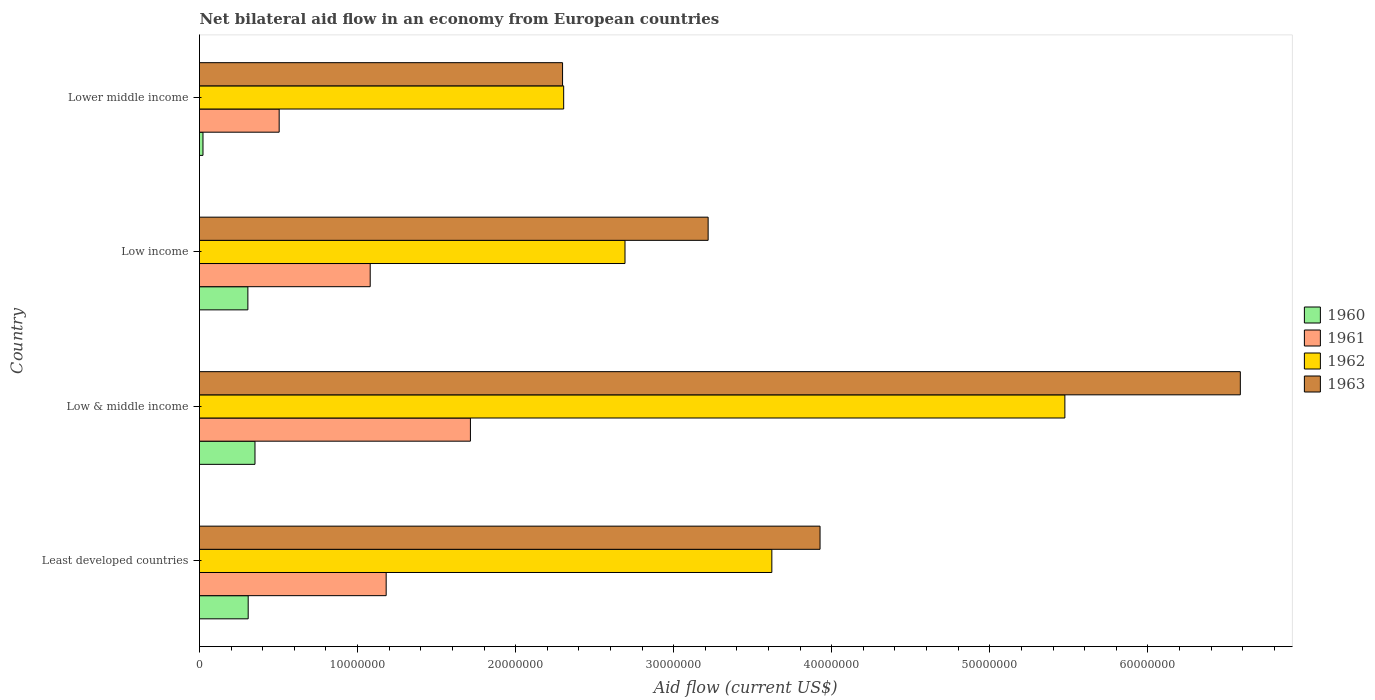How many different coloured bars are there?
Offer a terse response. 4. Are the number of bars per tick equal to the number of legend labels?
Offer a very short reply. Yes. Are the number of bars on each tick of the Y-axis equal?
Provide a short and direct response. Yes. How many bars are there on the 1st tick from the top?
Offer a terse response. 4. What is the label of the 2nd group of bars from the top?
Provide a succinct answer. Low income. What is the net bilateral aid flow in 1961 in Lower middle income?
Your answer should be compact. 5.04e+06. Across all countries, what is the maximum net bilateral aid flow in 1963?
Give a very brief answer. 6.58e+07. Across all countries, what is the minimum net bilateral aid flow in 1962?
Offer a terse response. 2.30e+07. In which country was the net bilateral aid flow in 1962 maximum?
Ensure brevity in your answer.  Low & middle income. In which country was the net bilateral aid flow in 1961 minimum?
Your answer should be very brief. Lower middle income. What is the total net bilateral aid flow in 1961 in the graph?
Offer a very short reply. 4.48e+07. What is the difference between the net bilateral aid flow in 1963 in Low & middle income and that in Low income?
Offer a very short reply. 3.37e+07. What is the difference between the net bilateral aid flow in 1962 in Lower middle income and the net bilateral aid flow in 1961 in Low income?
Give a very brief answer. 1.22e+07. What is the average net bilateral aid flow in 1961 per country?
Offer a terse response. 1.12e+07. What is the difference between the net bilateral aid flow in 1960 and net bilateral aid flow in 1963 in Lower middle income?
Offer a terse response. -2.28e+07. What is the ratio of the net bilateral aid flow in 1963 in Least developed countries to that in Low & middle income?
Make the answer very short. 0.6. Is the net bilateral aid flow in 1962 in Least developed countries less than that in Low income?
Offer a terse response. No. What is the difference between the highest and the second highest net bilateral aid flow in 1962?
Provide a succinct answer. 1.85e+07. What is the difference between the highest and the lowest net bilateral aid flow in 1963?
Provide a short and direct response. 4.29e+07. In how many countries, is the net bilateral aid flow in 1962 greater than the average net bilateral aid flow in 1962 taken over all countries?
Your response must be concise. 2. Is it the case that in every country, the sum of the net bilateral aid flow in 1961 and net bilateral aid flow in 1960 is greater than the sum of net bilateral aid flow in 1963 and net bilateral aid flow in 1962?
Your answer should be very brief. No. What does the 1st bar from the top in Lower middle income represents?
Give a very brief answer. 1963. Is it the case that in every country, the sum of the net bilateral aid flow in 1960 and net bilateral aid flow in 1961 is greater than the net bilateral aid flow in 1963?
Your answer should be compact. No. Are all the bars in the graph horizontal?
Your answer should be very brief. Yes. How many countries are there in the graph?
Your answer should be compact. 4. What is the difference between two consecutive major ticks on the X-axis?
Your answer should be very brief. 1.00e+07. Are the values on the major ticks of X-axis written in scientific E-notation?
Offer a terse response. No. How many legend labels are there?
Give a very brief answer. 4. How are the legend labels stacked?
Ensure brevity in your answer.  Vertical. What is the title of the graph?
Give a very brief answer. Net bilateral aid flow in an economy from European countries. Does "1988" appear as one of the legend labels in the graph?
Your answer should be very brief. No. What is the Aid flow (current US$) in 1960 in Least developed countries?
Keep it short and to the point. 3.08e+06. What is the Aid flow (current US$) in 1961 in Least developed countries?
Your response must be concise. 1.18e+07. What is the Aid flow (current US$) in 1962 in Least developed countries?
Your answer should be compact. 3.62e+07. What is the Aid flow (current US$) of 1963 in Least developed countries?
Offer a terse response. 3.93e+07. What is the Aid flow (current US$) of 1960 in Low & middle income?
Keep it short and to the point. 3.51e+06. What is the Aid flow (current US$) of 1961 in Low & middle income?
Your answer should be very brief. 1.71e+07. What is the Aid flow (current US$) in 1962 in Low & middle income?
Your answer should be compact. 5.48e+07. What is the Aid flow (current US$) in 1963 in Low & middle income?
Provide a short and direct response. 6.58e+07. What is the Aid flow (current US$) of 1960 in Low income?
Offer a terse response. 3.06e+06. What is the Aid flow (current US$) in 1961 in Low income?
Your answer should be very brief. 1.08e+07. What is the Aid flow (current US$) in 1962 in Low income?
Ensure brevity in your answer.  2.69e+07. What is the Aid flow (current US$) of 1963 in Low income?
Give a very brief answer. 3.22e+07. What is the Aid flow (current US$) of 1960 in Lower middle income?
Your answer should be very brief. 2.20e+05. What is the Aid flow (current US$) in 1961 in Lower middle income?
Make the answer very short. 5.04e+06. What is the Aid flow (current US$) in 1962 in Lower middle income?
Ensure brevity in your answer.  2.30e+07. What is the Aid flow (current US$) in 1963 in Lower middle income?
Ensure brevity in your answer.  2.30e+07. Across all countries, what is the maximum Aid flow (current US$) of 1960?
Provide a short and direct response. 3.51e+06. Across all countries, what is the maximum Aid flow (current US$) of 1961?
Offer a terse response. 1.71e+07. Across all countries, what is the maximum Aid flow (current US$) in 1962?
Make the answer very short. 5.48e+07. Across all countries, what is the maximum Aid flow (current US$) in 1963?
Offer a very short reply. 6.58e+07. Across all countries, what is the minimum Aid flow (current US$) in 1961?
Your answer should be very brief. 5.04e+06. Across all countries, what is the minimum Aid flow (current US$) of 1962?
Provide a short and direct response. 2.30e+07. Across all countries, what is the minimum Aid flow (current US$) of 1963?
Give a very brief answer. 2.30e+07. What is the total Aid flow (current US$) in 1960 in the graph?
Offer a terse response. 9.87e+06. What is the total Aid flow (current US$) of 1961 in the graph?
Offer a terse response. 4.48e+07. What is the total Aid flow (current US$) of 1962 in the graph?
Make the answer very short. 1.41e+08. What is the total Aid flow (current US$) of 1963 in the graph?
Provide a succinct answer. 1.60e+08. What is the difference between the Aid flow (current US$) in 1960 in Least developed countries and that in Low & middle income?
Your answer should be compact. -4.30e+05. What is the difference between the Aid flow (current US$) in 1961 in Least developed countries and that in Low & middle income?
Make the answer very short. -5.33e+06. What is the difference between the Aid flow (current US$) of 1962 in Least developed countries and that in Low & middle income?
Offer a terse response. -1.85e+07. What is the difference between the Aid flow (current US$) in 1963 in Least developed countries and that in Low & middle income?
Provide a short and direct response. -2.66e+07. What is the difference between the Aid flow (current US$) of 1961 in Least developed countries and that in Low income?
Provide a short and direct response. 1.01e+06. What is the difference between the Aid flow (current US$) in 1962 in Least developed countries and that in Low income?
Provide a short and direct response. 9.29e+06. What is the difference between the Aid flow (current US$) in 1963 in Least developed countries and that in Low income?
Your answer should be very brief. 7.08e+06. What is the difference between the Aid flow (current US$) of 1960 in Least developed countries and that in Lower middle income?
Make the answer very short. 2.86e+06. What is the difference between the Aid flow (current US$) of 1961 in Least developed countries and that in Lower middle income?
Give a very brief answer. 6.77e+06. What is the difference between the Aid flow (current US$) of 1962 in Least developed countries and that in Lower middle income?
Provide a short and direct response. 1.32e+07. What is the difference between the Aid flow (current US$) of 1963 in Least developed countries and that in Lower middle income?
Keep it short and to the point. 1.63e+07. What is the difference between the Aid flow (current US$) of 1961 in Low & middle income and that in Low income?
Keep it short and to the point. 6.34e+06. What is the difference between the Aid flow (current US$) of 1962 in Low & middle income and that in Low income?
Your response must be concise. 2.78e+07. What is the difference between the Aid flow (current US$) of 1963 in Low & middle income and that in Low income?
Your answer should be very brief. 3.37e+07. What is the difference between the Aid flow (current US$) of 1960 in Low & middle income and that in Lower middle income?
Your answer should be compact. 3.29e+06. What is the difference between the Aid flow (current US$) in 1961 in Low & middle income and that in Lower middle income?
Provide a succinct answer. 1.21e+07. What is the difference between the Aid flow (current US$) of 1962 in Low & middle income and that in Lower middle income?
Ensure brevity in your answer.  3.17e+07. What is the difference between the Aid flow (current US$) in 1963 in Low & middle income and that in Lower middle income?
Provide a succinct answer. 4.29e+07. What is the difference between the Aid flow (current US$) in 1960 in Low income and that in Lower middle income?
Provide a short and direct response. 2.84e+06. What is the difference between the Aid flow (current US$) in 1961 in Low income and that in Lower middle income?
Provide a short and direct response. 5.76e+06. What is the difference between the Aid flow (current US$) in 1962 in Low income and that in Lower middle income?
Offer a terse response. 3.88e+06. What is the difference between the Aid flow (current US$) in 1963 in Low income and that in Lower middle income?
Offer a very short reply. 9.21e+06. What is the difference between the Aid flow (current US$) of 1960 in Least developed countries and the Aid flow (current US$) of 1961 in Low & middle income?
Offer a terse response. -1.41e+07. What is the difference between the Aid flow (current US$) in 1960 in Least developed countries and the Aid flow (current US$) in 1962 in Low & middle income?
Ensure brevity in your answer.  -5.17e+07. What is the difference between the Aid flow (current US$) of 1960 in Least developed countries and the Aid flow (current US$) of 1963 in Low & middle income?
Keep it short and to the point. -6.28e+07. What is the difference between the Aid flow (current US$) of 1961 in Least developed countries and the Aid flow (current US$) of 1962 in Low & middle income?
Keep it short and to the point. -4.29e+07. What is the difference between the Aid flow (current US$) of 1961 in Least developed countries and the Aid flow (current US$) of 1963 in Low & middle income?
Provide a short and direct response. -5.40e+07. What is the difference between the Aid flow (current US$) in 1962 in Least developed countries and the Aid flow (current US$) in 1963 in Low & middle income?
Your answer should be very brief. -2.96e+07. What is the difference between the Aid flow (current US$) of 1960 in Least developed countries and the Aid flow (current US$) of 1961 in Low income?
Your answer should be very brief. -7.72e+06. What is the difference between the Aid flow (current US$) of 1960 in Least developed countries and the Aid flow (current US$) of 1962 in Low income?
Ensure brevity in your answer.  -2.38e+07. What is the difference between the Aid flow (current US$) of 1960 in Least developed countries and the Aid flow (current US$) of 1963 in Low income?
Keep it short and to the point. -2.91e+07. What is the difference between the Aid flow (current US$) of 1961 in Least developed countries and the Aid flow (current US$) of 1962 in Low income?
Ensure brevity in your answer.  -1.51e+07. What is the difference between the Aid flow (current US$) of 1961 in Least developed countries and the Aid flow (current US$) of 1963 in Low income?
Your answer should be compact. -2.04e+07. What is the difference between the Aid flow (current US$) of 1962 in Least developed countries and the Aid flow (current US$) of 1963 in Low income?
Offer a very short reply. 4.03e+06. What is the difference between the Aid flow (current US$) in 1960 in Least developed countries and the Aid flow (current US$) in 1961 in Lower middle income?
Your answer should be very brief. -1.96e+06. What is the difference between the Aid flow (current US$) in 1960 in Least developed countries and the Aid flow (current US$) in 1962 in Lower middle income?
Give a very brief answer. -2.00e+07. What is the difference between the Aid flow (current US$) in 1960 in Least developed countries and the Aid flow (current US$) in 1963 in Lower middle income?
Provide a succinct answer. -1.99e+07. What is the difference between the Aid flow (current US$) of 1961 in Least developed countries and the Aid flow (current US$) of 1962 in Lower middle income?
Your answer should be compact. -1.12e+07. What is the difference between the Aid flow (current US$) in 1961 in Least developed countries and the Aid flow (current US$) in 1963 in Lower middle income?
Offer a very short reply. -1.12e+07. What is the difference between the Aid flow (current US$) in 1962 in Least developed countries and the Aid flow (current US$) in 1963 in Lower middle income?
Offer a terse response. 1.32e+07. What is the difference between the Aid flow (current US$) of 1960 in Low & middle income and the Aid flow (current US$) of 1961 in Low income?
Your answer should be very brief. -7.29e+06. What is the difference between the Aid flow (current US$) of 1960 in Low & middle income and the Aid flow (current US$) of 1962 in Low income?
Make the answer very short. -2.34e+07. What is the difference between the Aid flow (current US$) of 1960 in Low & middle income and the Aid flow (current US$) of 1963 in Low income?
Ensure brevity in your answer.  -2.87e+07. What is the difference between the Aid flow (current US$) of 1961 in Low & middle income and the Aid flow (current US$) of 1962 in Low income?
Ensure brevity in your answer.  -9.78e+06. What is the difference between the Aid flow (current US$) in 1961 in Low & middle income and the Aid flow (current US$) in 1963 in Low income?
Your answer should be very brief. -1.50e+07. What is the difference between the Aid flow (current US$) of 1962 in Low & middle income and the Aid flow (current US$) of 1963 in Low income?
Make the answer very short. 2.26e+07. What is the difference between the Aid flow (current US$) of 1960 in Low & middle income and the Aid flow (current US$) of 1961 in Lower middle income?
Provide a short and direct response. -1.53e+06. What is the difference between the Aid flow (current US$) of 1960 in Low & middle income and the Aid flow (current US$) of 1962 in Lower middle income?
Ensure brevity in your answer.  -1.95e+07. What is the difference between the Aid flow (current US$) in 1960 in Low & middle income and the Aid flow (current US$) in 1963 in Lower middle income?
Offer a terse response. -1.95e+07. What is the difference between the Aid flow (current US$) of 1961 in Low & middle income and the Aid flow (current US$) of 1962 in Lower middle income?
Provide a succinct answer. -5.90e+06. What is the difference between the Aid flow (current US$) in 1961 in Low & middle income and the Aid flow (current US$) in 1963 in Lower middle income?
Keep it short and to the point. -5.83e+06. What is the difference between the Aid flow (current US$) in 1962 in Low & middle income and the Aid flow (current US$) in 1963 in Lower middle income?
Make the answer very short. 3.18e+07. What is the difference between the Aid flow (current US$) in 1960 in Low income and the Aid flow (current US$) in 1961 in Lower middle income?
Provide a succinct answer. -1.98e+06. What is the difference between the Aid flow (current US$) of 1960 in Low income and the Aid flow (current US$) of 1962 in Lower middle income?
Offer a terse response. -2.00e+07. What is the difference between the Aid flow (current US$) in 1960 in Low income and the Aid flow (current US$) in 1963 in Lower middle income?
Keep it short and to the point. -1.99e+07. What is the difference between the Aid flow (current US$) in 1961 in Low income and the Aid flow (current US$) in 1962 in Lower middle income?
Provide a short and direct response. -1.22e+07. What is the difference between the Aid flow (current US$) in 1961 in Low income and the Aid flow (current US$) in 1963 in Lower middle income?
Provide a short and direct response. -1.22e+07. What is the difference between the Aid flow (current US$) in 1962 in Low income and the Aid flow (current US$) in 1963 in Lower middle income?
Provide a short and direct response. 3.95e+06. What is the average Aid flow (current US$) in 1960 per country?
Provide a succinct answer. 2.47e+06. What is the average Aid flow (current US$) of 1961 per country?
Your answer should be very brief. 1.12e+07. What is the average Aid flow (current US$) in 1962 per country?
Your answer should be very brief. 3.52e+07. What is the average Aid flow (current US$) of 1963 per country?
Your answer should be compact. 4.01e+07. What is the difference between the Aid flow (current US$) of 1960 and Aid flow (current US$) of 1961 in Least developed countries?
Offer a very short reply. -8.73e+06. What is the difference between the Aid flow (current US$) of 1960 and Aid flow (current US$) of 1962 in Least developed countries?
Offer a terse response. -3.31e+07. What is the difference between the Aid flow (current US$) in 1960 and Aid flow (current US$) in 1963 in Least developed countries?
Your answer should be compact. -3.62e+07. What is the difference between the Aid flow (current US$) of 1961 and Aid flow (current US$) of 1962 in Least developed countries?
Your answer should be very brief. -2.44e+07. What is the difference between the Aid flow (current US$) of 1961 and Aid flow (current US$) of 1963 in Least developed countries?
Keep it short and to the point. -2.74e+07. What is the difference between the Aid flow (current US$) of 1962 and Aid flow (current US$) of 1963 in Least developed countries?
Provide a short and direct response. -3.05e+06. What is the difference between the Aid flow (current US$) in 1960 and Aid flow (current US$) in 1961 in Low & middle income?
Your answer should be very brief. -1.36e+07. What is the difference between the Aid flow (current US$) of 1960 and Aid flow (current US$) of 1962 in Low & middle income?
Offer a very short reply. -5.12e+07. What is the difference between the Aid flow (current US$) in 1960 and Aid flow (current US$) in 1963 in Low & middle income?
Ensure brevity in your answer.  -6.23e+07. What is the difference between the Aid flow (current US$) in 1961 and Aid flow (current US$) in 1962 in Low & middle income?
Your response must be concise. -3.76e+07. What is the difference between the Aid flow (current US$) of 1961 and Aid flow (current US$) of 1963 in Low & middle income?
Give a very brief answer. -4.87e+07. What is the difference between the Aid flow (current US$) in 1962 and Aid flow (current US$) in 1963 in Low & middle income?
Make the answer very short. -1.11e+07. What is the difference between the Aid flow (current US$) in 1960 and Aid flow (current US$) in 1961 in Low income?
Ensure brevity in your answer.  -7.74e+06. What is the difference between the Aid flow (current US$) of 1960 and Aid flow (current US$) of 1962 in Low income?
Offer a very short reply. -2.39e+07. What is the difference between the Aid flow (current US$) of 1960 and Aid flow (current US$) of 1963 in Low income?
Your answer should be very brief. -2.91e+07. What is the difference between the Aid flow (current US$) of 1961 and Aid flow (current US$) of 1962 in Low income?
Your answer should be very brief. -1.61e+07. What is the difference between the Aid flow (current US$) of 1961 and Aid flow (current US$) of 1963 in Low income?
Make the answer very short. -2.14e+07. What is the difference between the Aid flow (current US$) in 1962 and Aid flow (current US$) in 1963 in Low income?
Provide a succinct answer. -5.26e+06. What is the difference between the Aid flow (current US$) in 1960 and Aid flow (current US$) in 1961 in Lower middle income?
Your answer should be compact. -4.82e+06. What is the difference between the Aid flow (current US$) of 1960 and Aid flow (current US$) of 1962 in Lower middle income?
Provide a succinct answer. -2.28e+07. What is the difference between the Aid flow (current US$) of 1960 and Aid flow (current US$) of 1963 in Lower middle income?
Provide a succinct answer. -2.28e+07. What is the difference between the Aid flow (current US$) in 1961 and Aid flow (current US$) in 1962 in Lower middle income?
Offer a terse response. -1.80e+07. What is the difference between the Aid flow (current US$) of 1961 and Aid flow (current US$) of 1963 in Lower middle income?
Your response must be concise. -1.79e+07. What is the difference between the Aid flow (current US$) of 1962 and Aid flow (current US$) of 1963 in Lower middle income?
Your response must be concise. 7.00e+04. What is the ratio of the Aid flow (current US$) in 1960 in Least developed countries to that in Low & middle income?
Your response must be concise. 0.88. What is the ratio of the Aid flow (current US$) in 1961 in Least developed countries to that in Low & middle income?
Make the answer very short. 0.69. What is the ratio of the Aid flow (current US$) of 1962 in Least developed countries to that in Low & middle income?
Offer a terse response. 0.66. What is the ratio of the Aid flow (current US$) of 1963 in Least developed countries to that in Low & middle income?
Make the answer very short. 0.6. What is the ratio of the Aid flow (current US$) in 1961 in Least developed countries to that in Low income?
Your answer should be compact. 1.09. What is the ratio of the Aid flow (current US$) in 1962 in Least developed countries to that in Low income?
Ensure brevity in your answer.  1.35. What is the ratio of the Aid flow (current US$) in 1963 in Least developed countries to that in Low income?
Make the answer very short. 1.22. What is the ratio of the Aid flow (current US$) of 1960 in Least developed countries to that in Lower middle income?
Provide a short and direct response. 14. What is the ratio of the Aid flow (current US$) of 1961 in Least developed countries to that in Lower middle income?
Offer a very short reply. 2.34. What is the ratio of the Aid flow (current US$) in 1962 in Least developed countries to that in Lower middle income?
Offer a terse response. 1.57. What is the ratio of the Aid flow (current US$) of 1963 in Least developed countries to that in Lower middle income?
Offer a terse response. 1.71. What is the ratio of the Aid flow (current US$) of 1960 in Low & middle income to that in Low income?
Your answer should be compact. 1.15. What is the ratio of the Aid flow (current US$) of 1961 in Low & middle income to that in Low income?
Give a very brief answer. 1.59. What is the ratio of the Aid flow (current US$) in 1962 in Low & middle income to that in Low income?
Give a very brief answer. 2.03. What is the ratio of the Aid flow (current US$) in 1963 in Low & middle income to that in Low income?
Your response must be concise. 2.05. What is the ratio of the Aid flow (current US$) of 1960 in Low & middle income to that in Lower middle income?
Your answer should be compact. 15.95. What is the ratio of the Aid flow (current US$) of 1961 in Low & middle income to that in Lower middle income?
Provide a short and direct response. 3.4. What is the ratio of the Aid flow (current US$) in 1962 in Low & middle income to that in Lower middle income?
Your response must be concise. 2.38. What is the ratio of the Aid flow (current US$) in 1963 in Low & middle income to that in Lower middle income?
Keep it short and to the point. 2.87. What is the ratio of the Aid flow (current US$) in 1960 in Low income to that in Lower middle income?
Offer a very short reply. 13.91. What is the ratio of the Aid flow (current US$) in 1961 in Low income to that in Lower middle income?
Ensure brevity in your answer.  2.14. What is the ratio of the Aid flow (current US$) in 1962 in Low income to that in Lower middle income?
Ensure brevity in your answer.  1.17. What is the ratio of the Aid flow (current US$) in 1963 in Low income to that in Lower middle income?
Keep it short and to the point. 1.4. What is the difference between the highest and the second highest Aid flow (current US$) in 1961?
Provide a succinct answer. 5.33e+06. What is the difference between the highest and the second highest Aid flow (current US$) of 1962?
Make the answer very short. 1.85e+07. What is the difference between the highest and the second highest Aid flow (current US$) in 1963?
Give a very brief answer. 2.66e+07. What is the difference between the highest and the lowest Aid flow (current US$) of 1960?
Make the answer very short. 3.29e+06. What is the difference between the highest and the lowest Aid flow (current US$) in 1961?
Give a very brief answer. 1.21e+07. What is the difference between the highest and the lowest Aid flow (current US$) in 1962?
Provide a short and direct response. 3.17e+07. What is the difference between the highest and the lowest Aid flow (current US$) in 1963?
Your answer should be compact. 4.29e+07. 